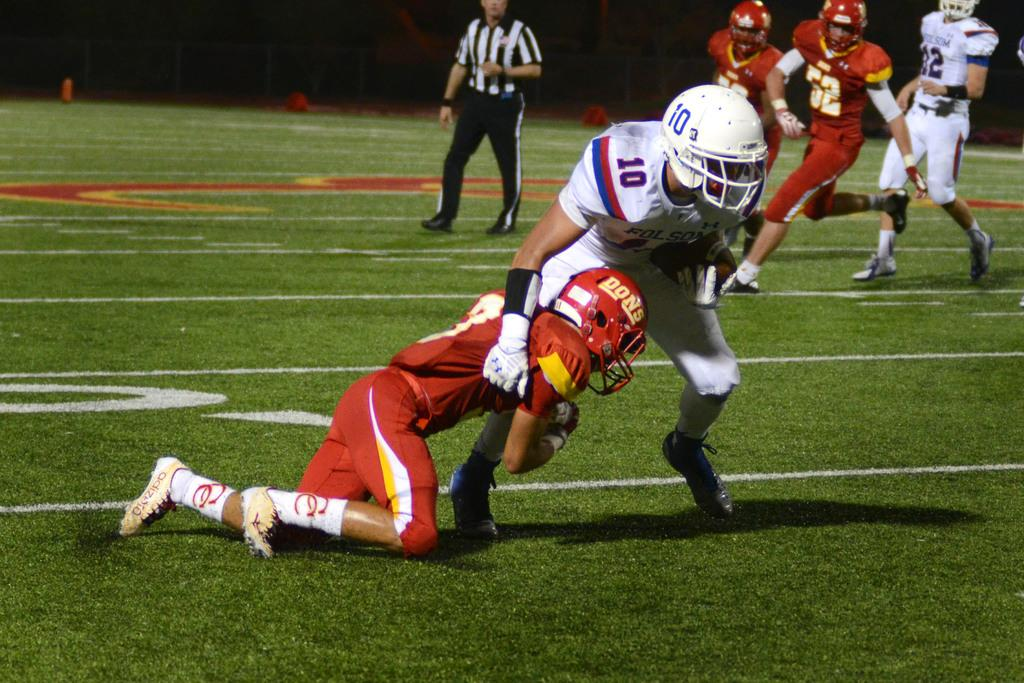How many people are in the image? There are six persons in the image. What is the position of the persons in the image? The persons are on the ground. What can be observed about the background of the image? The background of the image is dark. What type of engine can be seen in the image? There is no engine present in the image. What historical event is depicted in the image? There is no historical event depicted in the image; it features six persons on the ground with a dark background. 